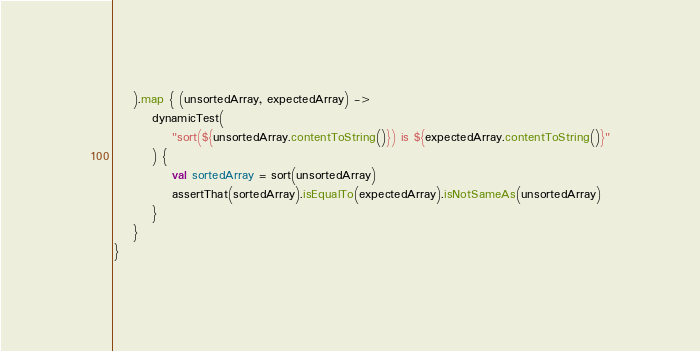Convert code to text. <code><loc_0><loc_0><loc_500><loc_500><_Kotlin_>	).map { (unsortedArray, expectedArray) ->
		dynamicTest(
			"sort(${unsortedArray.contentToString()}) is ${expectedArray.contentToString()}"
		) {
			val sortedArray = sort(unsortedArray)
			assertThat(sortedArray).isEqualTo(expectedArray).isNotSameAs(unsortedArray)
		}
	}
}
</code> 